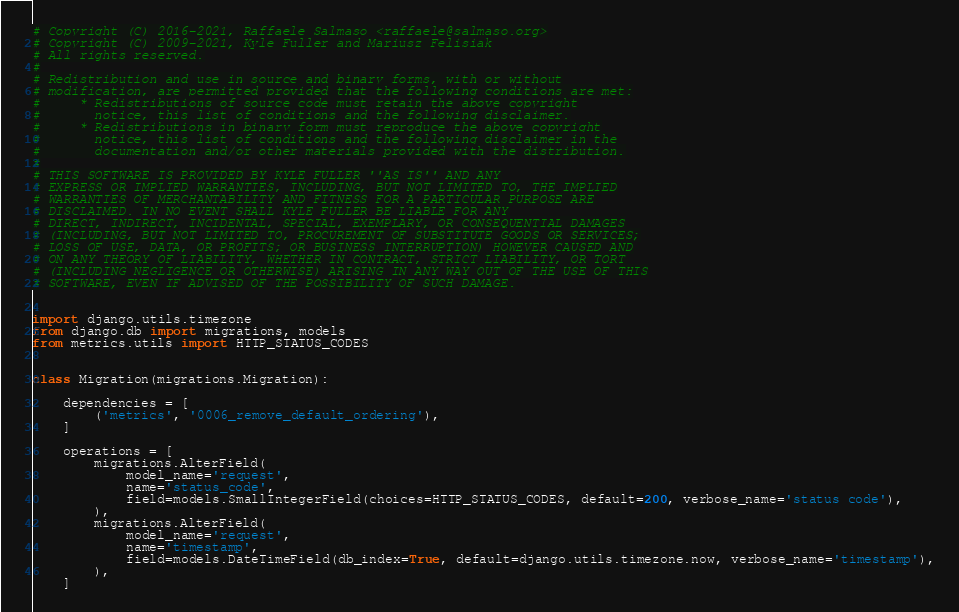<code> <loc_0><loc_0><loc_500><loc_500><_Python_># Copyright (C) 2016-2021, Raffaele Salmaso <raffaele@salmaso.org>
# Copyright (C) 2009-2021, Kyle Fuller and Mariusz Felisiak
# All rights reserved.
#
# Redistribution and use in source and binary forms, with or without
# modification, are permitted provided that the following conditions are met:
#     * Redistributions of source code must retain the above copyright
#       notice, this list of conditions and the following disclaimer.
#     * Redistributions in binary form must reproduce the above copyright
#       notice, this list of conditions and the following disclaimer in the
#       documentation and/or other materials provided with the distribution.
#
# THIS SOFTWARE IS PROVIDED BY KYLE FULLER ''AS IS'' AND ANY
# EXPRESS OR IMPLIED WARRANTIES, INCLUDING, BUT NOT LIMITED TO, THE IMPLIED
# WARRANTIES OF MERCHANTABILITY AND FITNESS FOR A PARTICULAR PURPOSE ARE
# DISCLAIMED. IN NO EVENT SHALL KYLE FULLER BE LIABLE FOR ANY
# DIRECT, INDIRECT, INCIDENTAL, SPECIAL, EXEMPLARY, OR CONSEQUENTIAL DAMAGES
# (INCLUDING, BUT NOT LIMITED TO, PROCUREMENT OF SUBSTITUTE GOODS OR SERVICES;
# LOSS OF USE, DATA, OR PROFITS; OR BUSINESS INTERRUPTION) HOWEVER CAUSED AND
# ON ANY THEORY OF LIABILITY, WHETHER IN CONTRACT, STRICT LIABILITY, OR TORT
# (INCLUDING NEGLIGENCE OR OTHERWISE) ARISING IN ANY WAY OUT OF THE USE OF THIS
# SOFTWARE, EVEN IF ADVISED OF THE POSSIBILITY OF SUCH DAMAGE.


import django.utils.timezone
from django.db import migrations, models
from metrics.utils import HTTP_STATUS_CODES


class Migration(migrations.Migration):

    dependencies = [
        ('metrics', '0006_remove_default_ordering'),
    ]

    operations = [
        migrations.AlterField(
            model_name='request',
            name='status_code',
            field=models.SmallIntegerField(choices=HTTP_STATUS_CODES, default=200, verbose_name='status code'),
        ),
        migrations.AlterField(
            model_name='request',
            name='timestamp',
            field=models.DateTimeField(db_index=True, default=django.utils.timezone.now, verbose_name='timestamp'),
        ),
    ]
</code> 